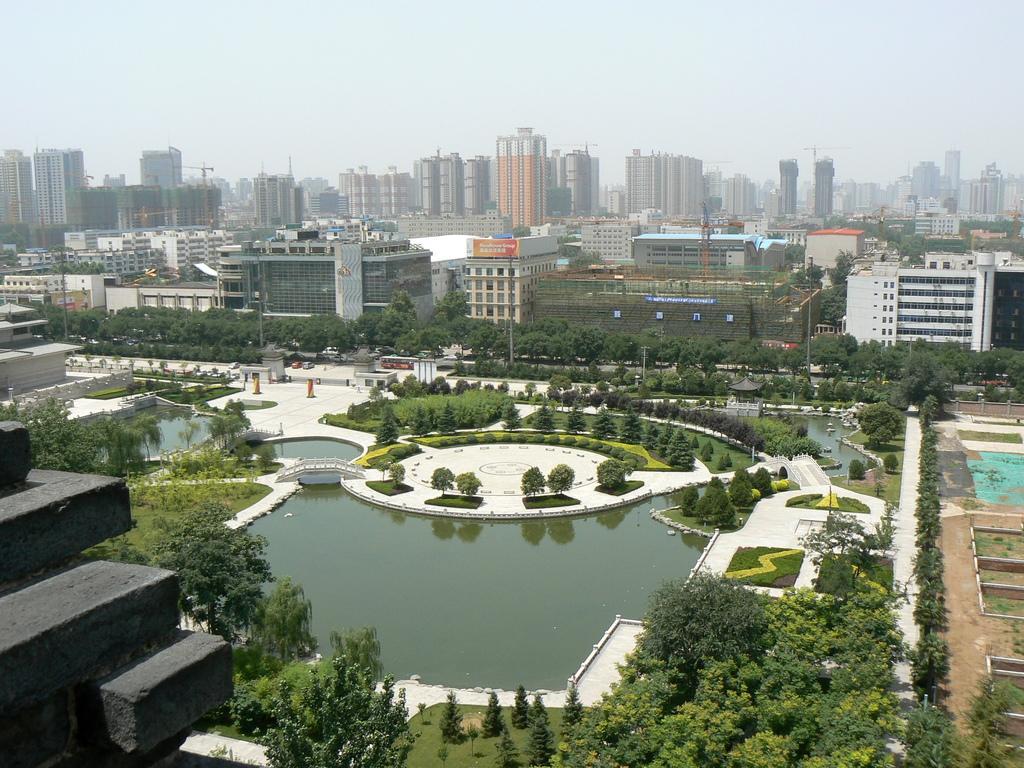How would you summarize this image in a sentence or two? In this image there is water surrounded by the floor having few trees and plants on the grass land. There are few buildings. Top of image is sky. There are few vehicles on the road. On grassland there are few trees. 